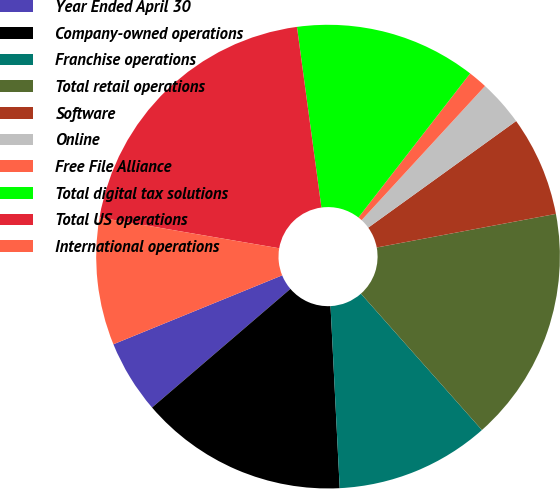Convert chart. <chart><loc_0><loc_0><loc_500><loc_500><pie_chart><fcel>Year Ended April 30<fcel>Company-owned operations<fcel>Franchise operations<fcel>Total retail operations<fcel>Software<fcel>Online<fcel>Free File Alliance<fcel>Total digital tax solutions<fcel>Total US operations<fcel>International operations<nl><fcel>5.11%<fcel>14.52%<fcel>10.75%<fcel>16.4%<fcel>6.99%<fcel>3.22%<fcel>1.34%<fcel>12.64%<fcel>20.16%<fcel>8.87%<nl></chart> 